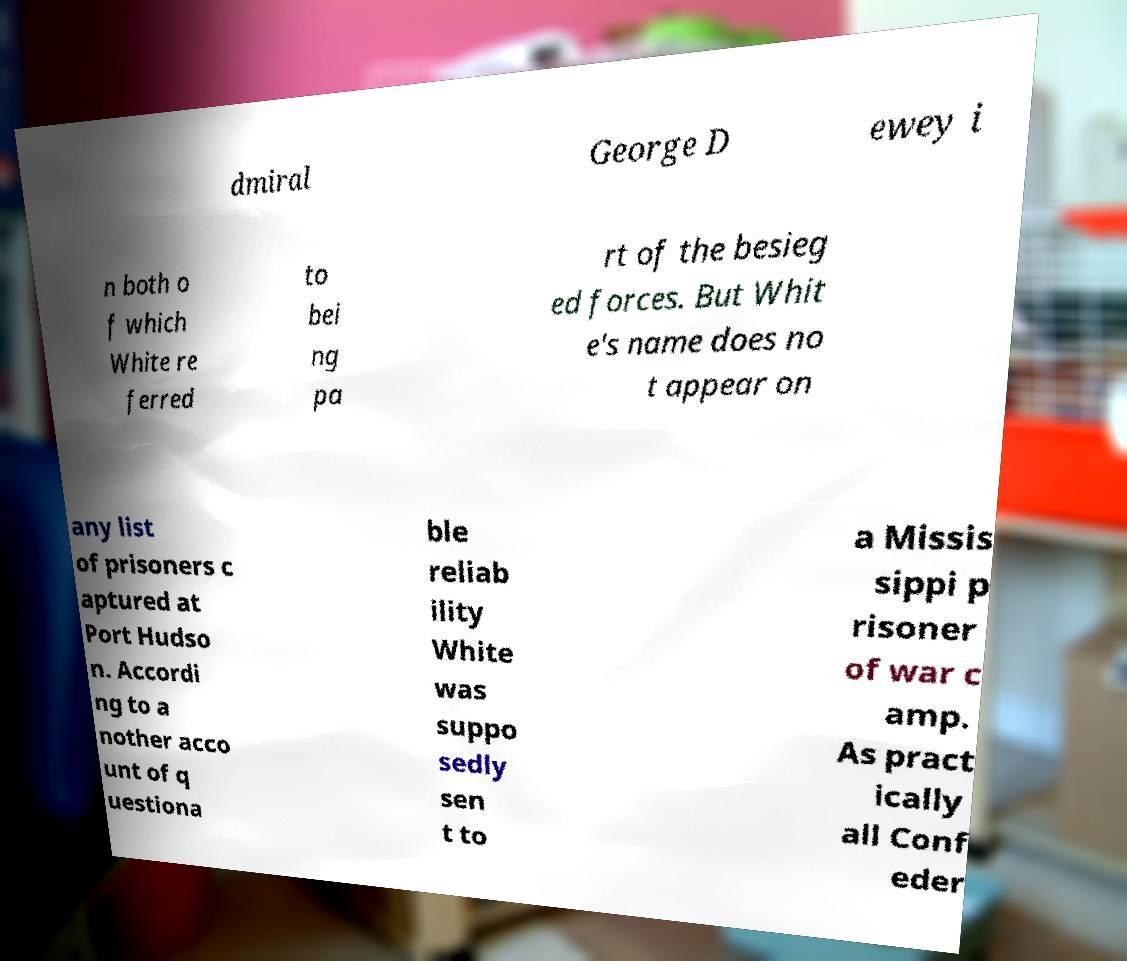Could you extract and type out the text from this image? dmiral George D ewey i n both o f which White re ferred to bei ng pa rt of the besieg ed forces. But Whit e's name does no t appear on any list of prisoners c aptured at Port Hudso n. Accordi ng to a nother acco unt of q uestiona ble reliab ility White was suppo sedly sen t to a Missis sippi p risoner of war c amp. As pract ically all Conf eder 